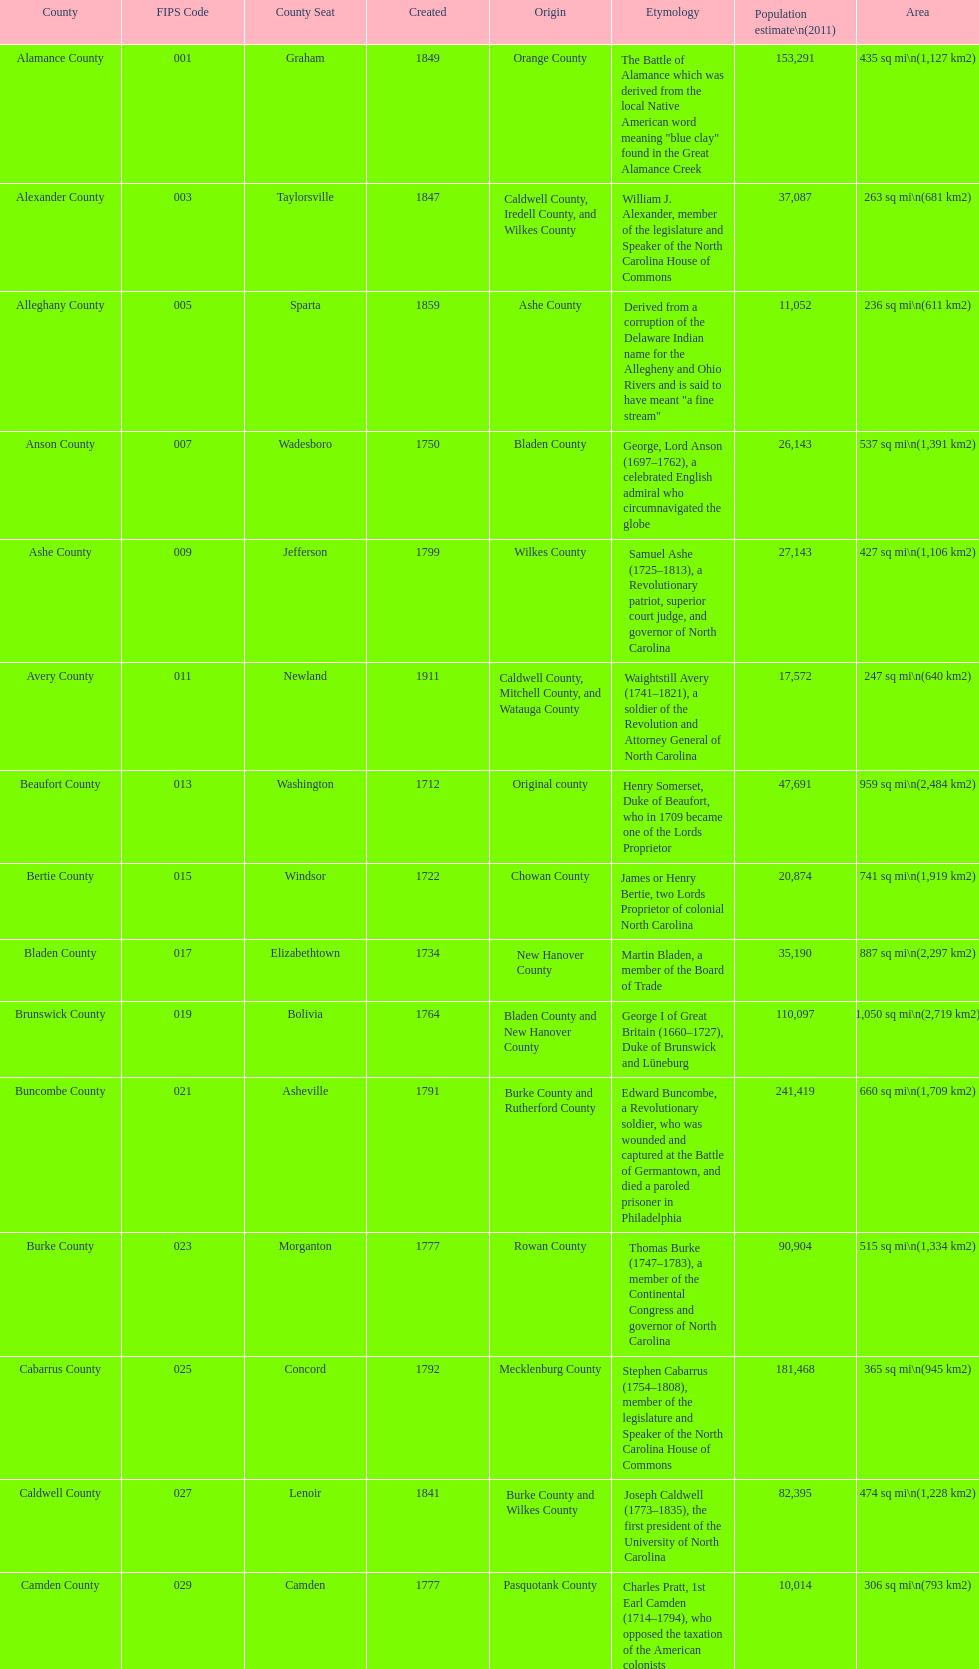Which is the only county with a name derived from a battle? Alamance County. 